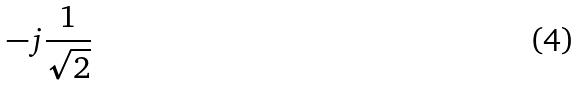Convert formula to latex. <formula><loc_0><loc_0><loc_500><loc_500>- j \frac { 1 } { \sqrt { 2 } }</formula> 